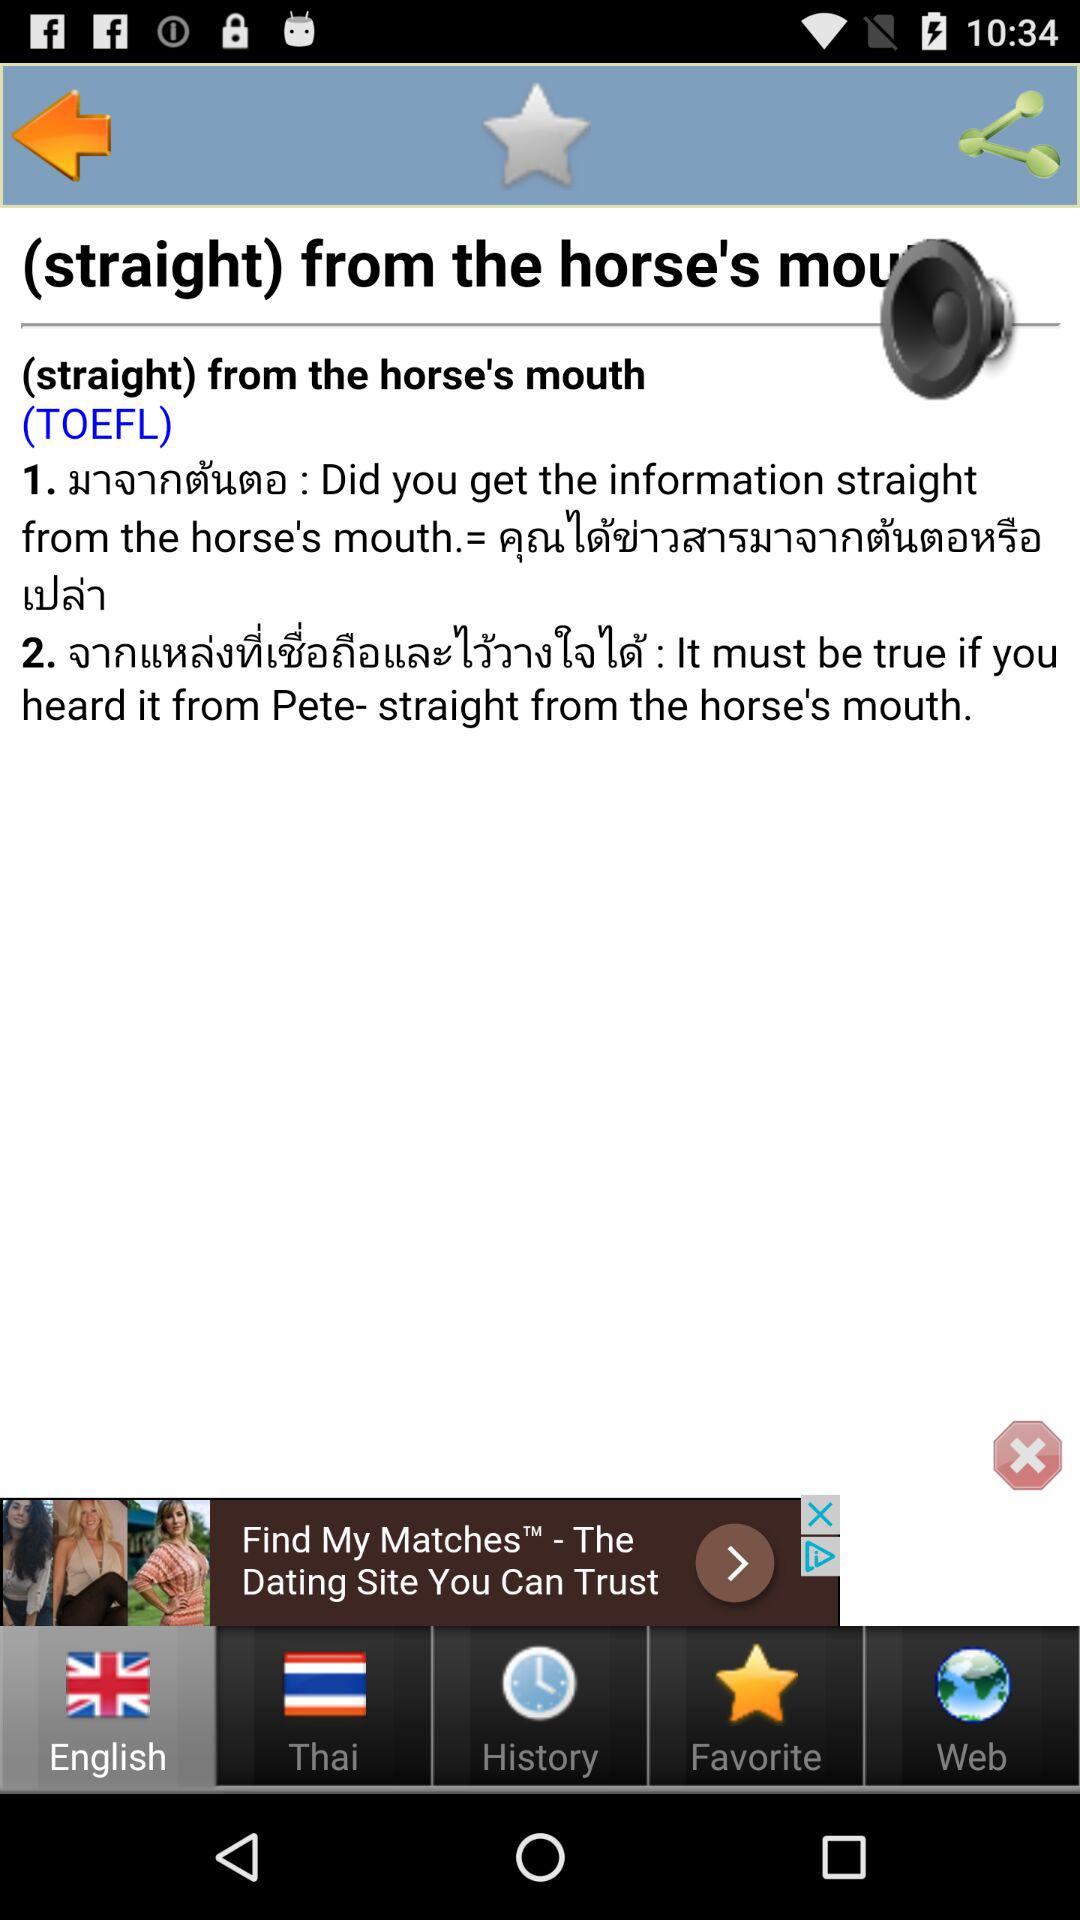How many languages are available for this app?
Answer the question using a single word or phrase. 2 